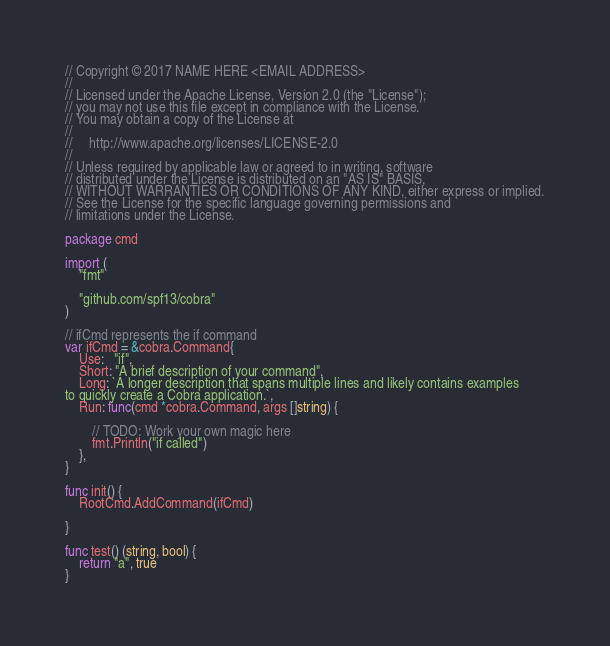Convert code to text. <code><loc_0><loc_0><loc_500><loc_500><_Go_>// Copyright © 2017 NAME HERE <EMAIL ADDRESS>
//
// Licensed under the Apache License, Version 2.0 (the "License");
// you may not use this file except in compliance with the License.
// You may obtain a copy of the License at
//
//     http://www.apache.org/licenses/LICENSE-2.0
//
// Unless required by applicable law or agreed to in writing, software
// distributed under the License is distributed on an "AS IS" BASIS,
// WITHOUT WARRANTIES OR CONDITIONS OF ANY KIND, either express or implied.
// See the License for the specific language governing permissions and
// limitations under the License.

package cmd

import (
	"fmt"

	"github.com/spf13/cobra"
)

// ifCmd represents the if command
var ifCmd = &cobra.Command{
	Use:   "if",
	Short: "A brief description of your command",
	Long: `A longer description that spans multiple lines and likely contains examples
to quickly create a Cobra application.`,
	Run: func(cmd *cobra.Command, args []string) {

		// TODO: Work your own magic here
		fmt.Println("if called")
	},
}

func init() {
	RootCmd.AddCommand(ifCmd)

}

func test() (string, bool) {
	return "a", true
}
</code> 